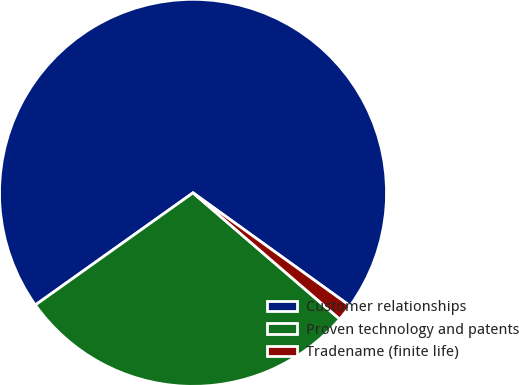Convert chart. <chart><loc_0><loc_0><loc_500><loc_500><pie_chart><fcel>Customer relationships<fcel>Proven technology and patents<fcel>Tradename (finite life)<nl><fcel>69.77%<fcel>28.85%<fcel>1.38%<nl></chart> 